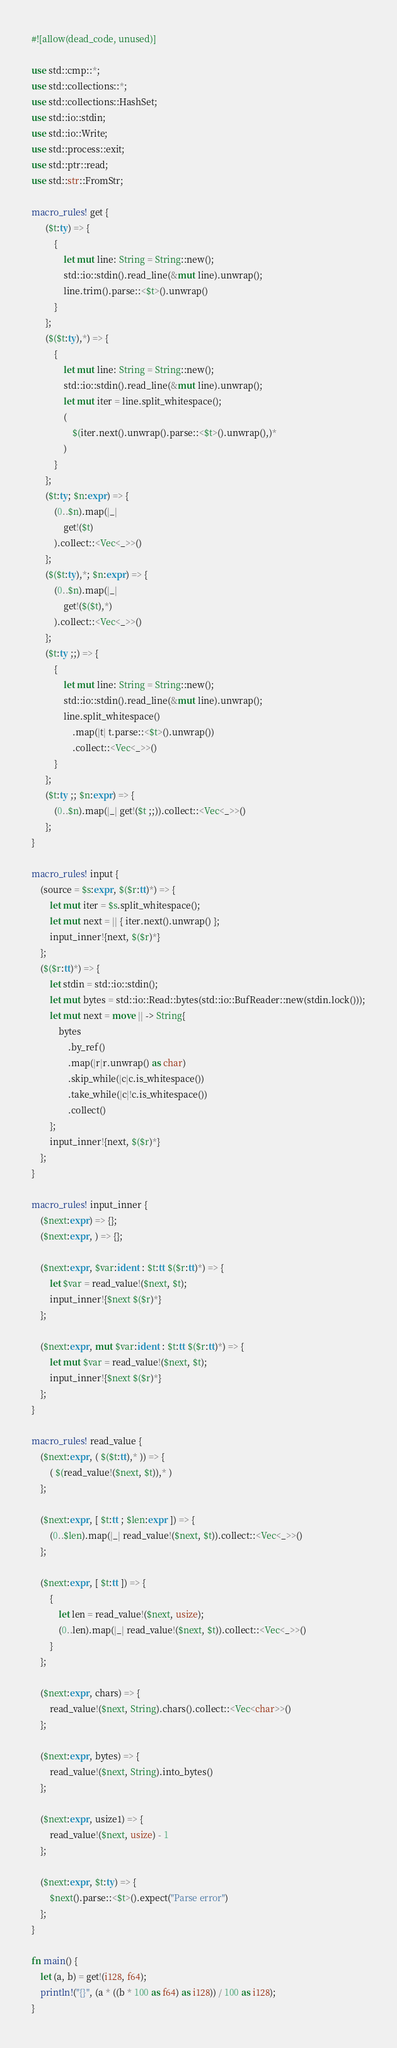Convert code to text. <code><loc_0><loc_0><loc_500><loc_500><_Rust_>#![allow(dead_code, unused)]

use std::cmp::*;
use std::collections::*;
use std::collections::HashSet;
use std::io::stdin;
use std::io::Write;
use std::process::exit;
use std::ptr::read;
use std::str::FromStr;

macro_rules! get {
      ($t:ty) => {
          {
              let mut line: String = String::new();
              std::io::stdin().read_line(&mut line).unwrap();
              line.trim().parse::<$t>().unwrap()
          }
      };
      ($($t:ty),*) => {
          {
              let mut line: String = String::new();
              std::io::stdin().read_line(&mut line).unwrap();
              let mut iter = line.split_whitespace();
              (
                  $(iter.next().unwrap().parse::<$t>().unwrap(),)*
              )
          }
      };
      ($t:ty; $n:expr) => {
          (0..$n).map(|_|
              get!($t)
          ).collect::<Vec<_>>()
      };
      ($($t:ty),*; $n:expr) => {
          (0..$n).map(|_|
              get!($($t),*)
          ).collect::<Vec<_>>()
      };
      ($t:ty ;;) => {
          {
              let mut line: String = String::new();
              std::io::stdin().read_line(&mut line).unwrap();
              line.split_whitespace()
                  .map(|t| t.parse::<$t>().unwrap())
                  .collect::<Vec<_>>()
          }
      };
      ($t:ty ;; $n:expr) => {
          (0..$n).map(|_| get!($t ;;)).collect::<Vec<_>>()
      };
}

macro_rules! input {
    (source = $s:expr, $($r:tt)*) => {
        let mut iter = $s.split_whitespace();
        let mut next = || { iter.next().unwrap() };
        input_inner!{next, $($r)*}
    };
    ($($r:tt)*) => {
        let stdin = std::io::stdin();
        let mut bytes = std::io::Read::bytes(std::io::BufReader::new(stdin.lock()));
        let mut next = move || -> String{
            bytes
                .by_ref()
                .map(|r|r.unwrap() as char)
                .skip_while(|c|c.is_whitespace())
                .take_while(|c|!c.is_whitespace())
                .collect()
        };
        input_inner!{next, $($r)*}
    };
}

macro_rules! input_inner {
    ($next:expr) => {};
    ($next:expr, ) => {};

    ($next:expr, $var:ident : $t:tt $($r:tt)*) => {
        let $var = read_value!($next, $t);
        input_inner!{$next $($r)*}
    };

    ($next:expr, mut $var:ident : $t:tt $($r:tt)*) => {
        let mut $var = read_value!($next, $t);
        input_inner!{$next $($r)*}
    };
}

macro_rules! read_value {
    ($next:expr, ( $($t:tt),* )) => {
        ( $(read_value!($next, $t)),* )
    };

    ($next:expr, [ $t:tt ; $len:expr ]) => {
        (0..$len).map(|_| read_value!($next, $t)).collect::<Vec<_>>()
    };

    ($next:expr, [ $t:tt ]) => {
        {
            let len = read_value!($next, usize);
            (0..len).map(|_| read_value!($next, $t)).collect::<Vec<_>>()
        }
    };

    ($next:expr, chars) => {
        read_value!($next, String).chars().collect::<Vec<char>>()
    };

    ($next:expr, bytes) => {
        read_value!($next, String).into_bytes()
    };

    ($next:expr, usize1) => {
        read_value!($next, usize) - 1
    };

    ($next:expr, $t:ty) => {
        $next().parse::<$t>().expect("Parse error")
    };
}

fn main() {
    let (a, b) = get!(i128, f64);
    println!("{}", (a * ((b * 100 as f64) as i128)) / 100 as i128);
}</code> 